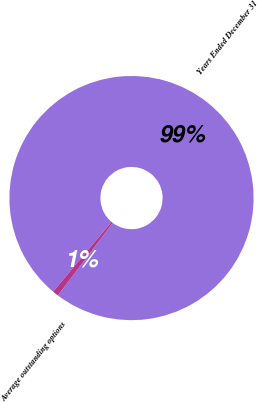<chart> <loc_0><loc_0><loc_500><loc_500><pie_chart><fcel>Years Ended December 31<fcel>Average outstanding options<nl><fcel>99.21%<fcel>0.79%<nl></chart> 